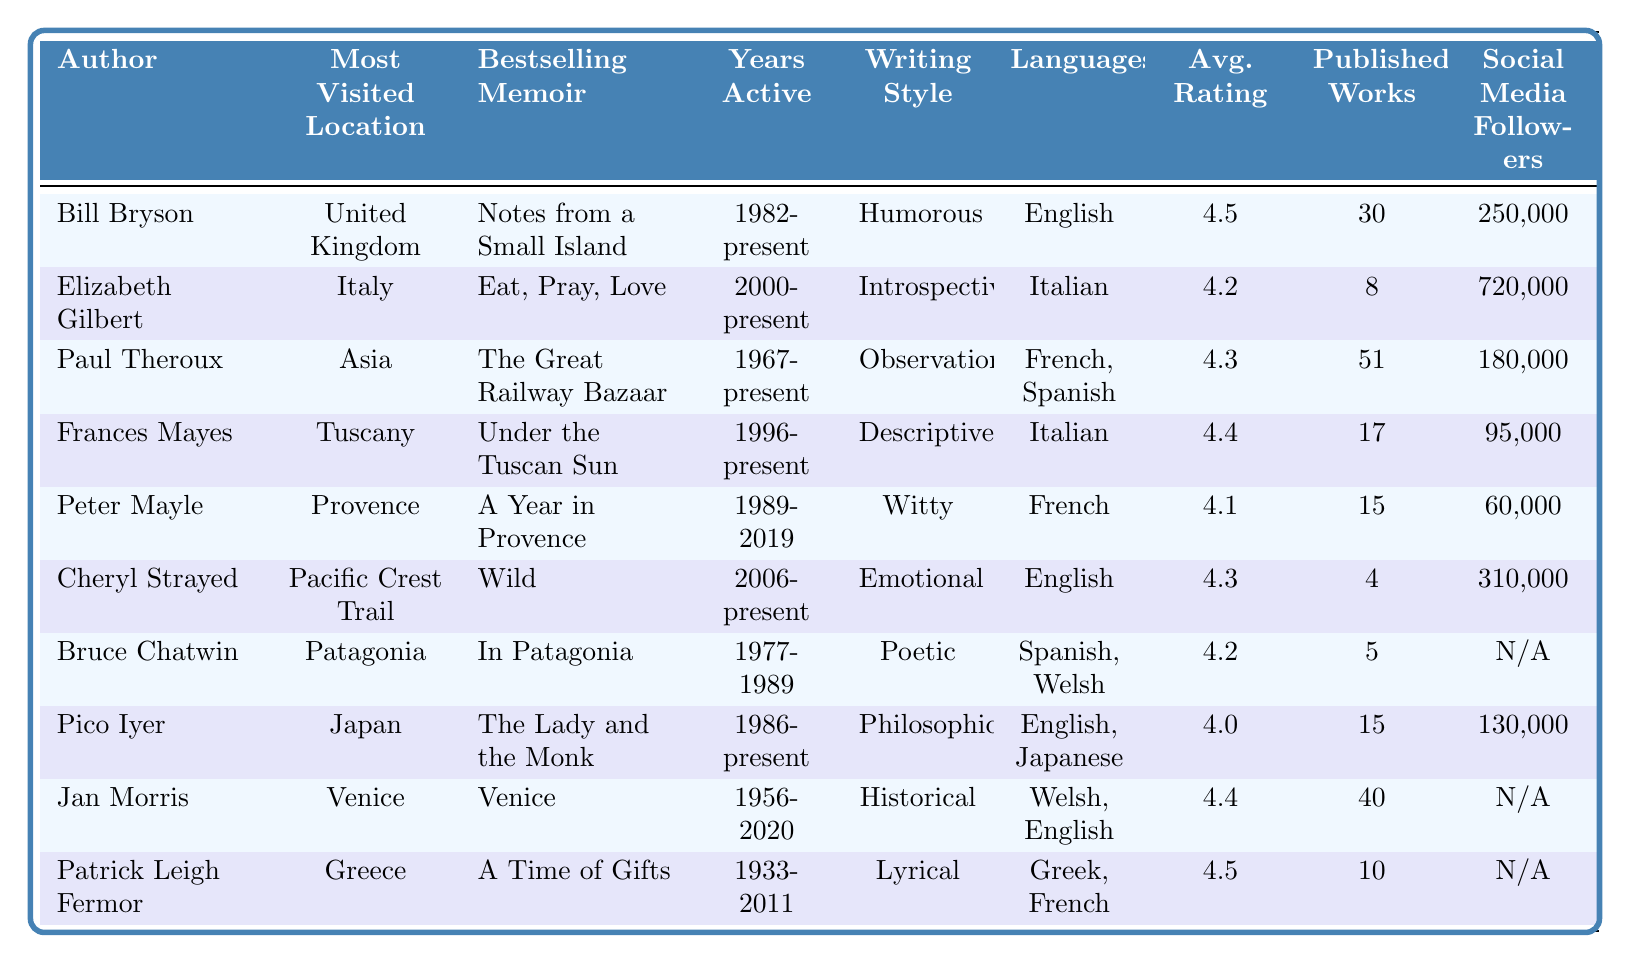What is the bestselling memoir of Bill Bryson? The table lists "Notes from a Small Island" as the bestselling memoir of Bill Bryson, found in the column dedicated to bestselling memoirs next to his name.
Answer: Notes from a Small Island Which author has the longest active writing career? Paul Theroux has been active since 1967, making his writing career span 56 years. This information comes from the column detailing the years each author has been active.
Answer: Paul Theroux How many authors have an average book rating of 4.5 or higher? Counting the entries with an average book rating of 4.5 or more shows that Bill Bryson, Frances Mayes, Jan Morris, and Patrick Leigh Fermor equal four authors overall.
Answer: Four Is it true that Cheryl Strayed has published more than ten works? The table indicates that Cheryl Strayed has only published 4 works, thus confirming that the statement is false.
Answer: False Which location is most frequently visited by authors in the table? By examining the unique locations listed for each author, "United Kingdom" appears only once as the most frequently referenced, alongside it, no other location stands out as more frequently visited.
Answer: United Kingdom What is the average rating of the bestsellers from authors who primarily write in English? The English writers are Bill Bryson (4.5), Cheryl Strayed (4.3), Pico Iyer (4.0), Jan Morris (4.4), and the average rating is calculated as (4.5 + 4.3 + 4.0 + 4.4) / 4 = 4.3.
Answer: 4.3 How many authors regularly visit locations that are not in Europe? The authors who visit non-European locations are Paul Theroux (Asia), Cheryl Strayed (Pacific Crest Trail), and Bruce Chatwin (Patagonia), resulting in three authors.
Answer: Three Which author's writing style is both emotional and humorous? The table indicates that no author is listed with both emotional and humorous writing styles; each author has a distinct writing style.
Answer: None What is the total number of published works by authors active after 2000? The active authors after 2000 are Elizabeth Gilbert (8), Cheryl Strayed (4), and Paul Theroux (51); thus, the total is calculated as 8 + 4 + 51 = 63.
Answer: 63 Which author has the most social media followers based on the data provided? Comparing the number of social media followers reveals that Elizabeth Gilbert has the highest count at 720,000 followers listed under her row in the followers column.
Answer: Elizabeth Gilbert 